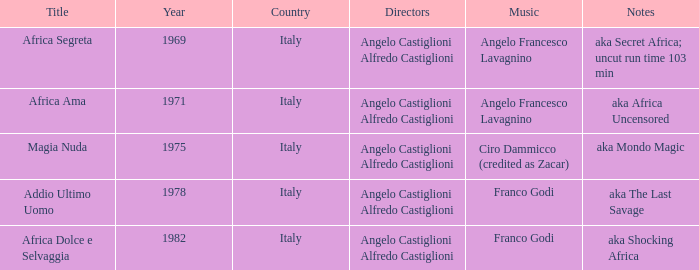How many years have a Title of Magia Nuda? 1.0. 